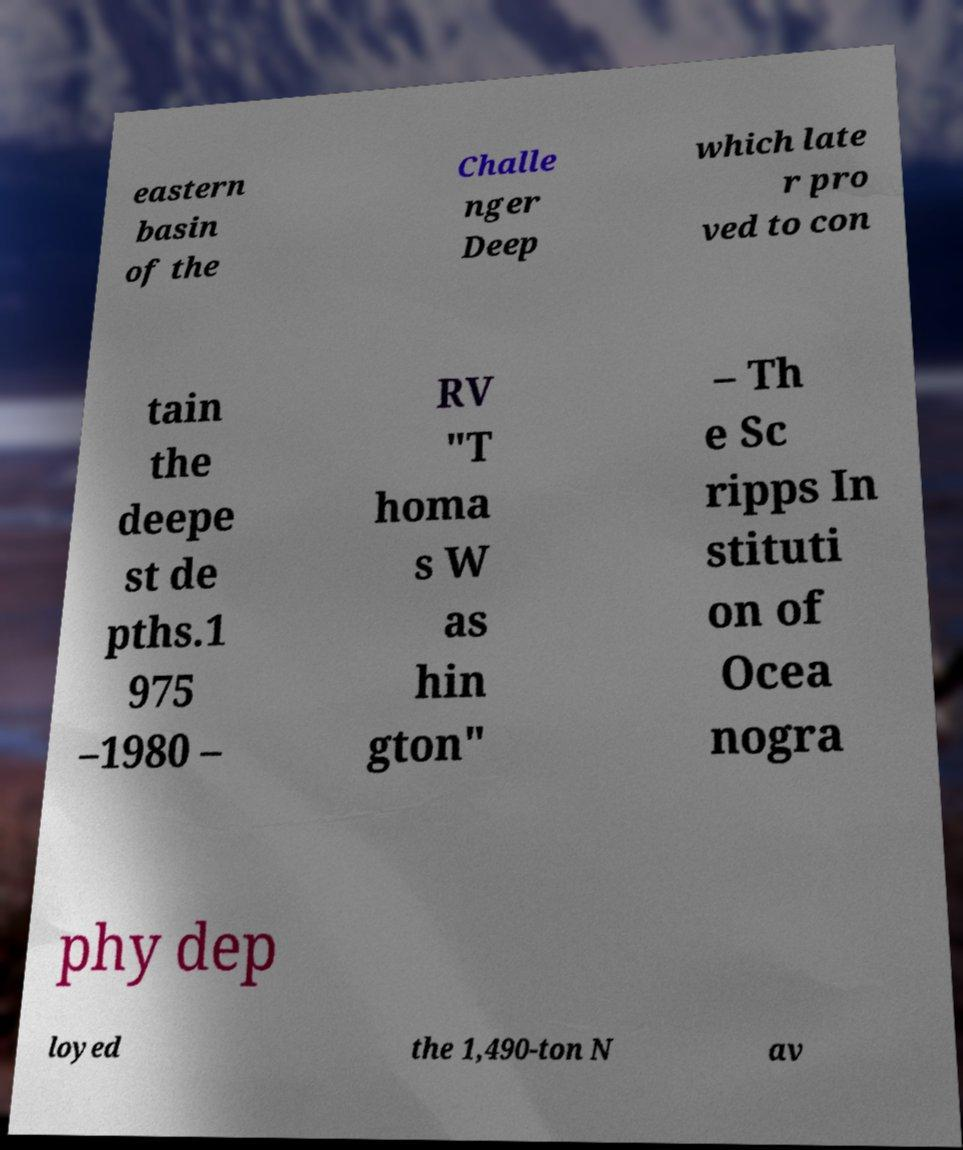Can you accurately transcribe the text from the provided image for me? eastern basin of the Challe nger Deep which late r pro ved to con tain the deepe st de pths.1 975 –1980 – RV "T homa s W as hin gton" – Th e Sc ripps In stituti on of Ocea nogra phy dep loyed the 1,490-ton N av 